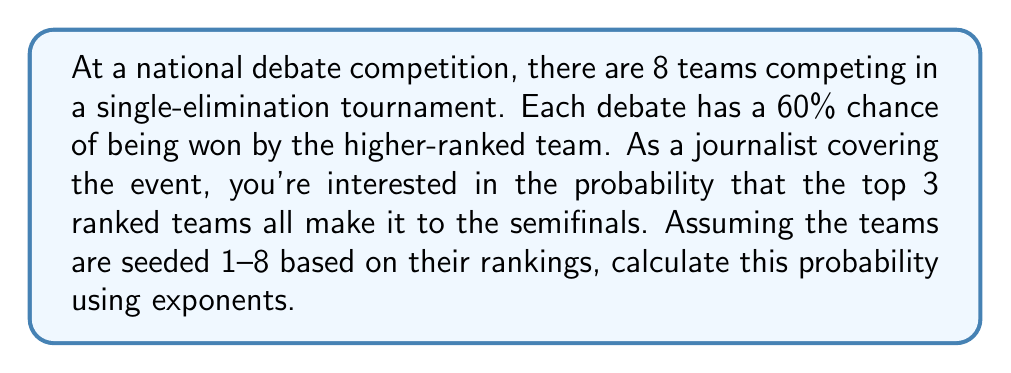Show me your answer to this math problem. Let's approach this step-by-step:

1) In a single-elimination tournament with 8 teams, there are 3 rounds: quarterfinals, semifinals, and finals.

2) For the top 3 teams to reach the semifinals, they each need to win their quarterfinal match.

3) The probability of each higher-ranked team winning is 0.6 or 60%.

4) For the #1 seed:
   - They face the #8 seed in the quarterfinals
   - Probability of winning: $0.6$

5) For the #2 seed:
   - They face the #7 seed in the quarterfinals
   - Probability of winning: $0.6$

6) For the #3 seed:
   - They face the #6 seed in the quarterfinals
   - Probability of winning: $0.6$

7) For all three to make it to the semifinals, all three events must occur independently.

8) We can calculate this using the multiplication rule of probability:

   $P(\text{all 3 in semifinals}) = 0.6 \times 0.6 \times 0.6 = 0.6^3$

9) Calculate $0.6^3$:
   $0.6^3 = 0.216$

Therefore, the probability that the top 3 ranked teams all make it to the semifinals is 0.216 or 21.6%.
Answer: $0.216$ or $21.6\%$ 